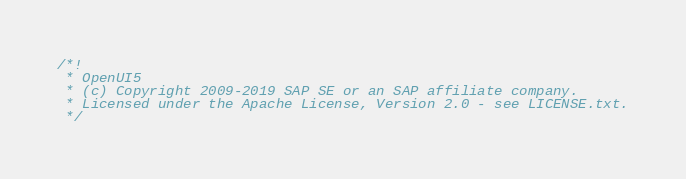Convert code to text. <code><loc_0><loc_0><loc_500><loc_500><_JavaScript_>/*!
 * OpenUI5
 * (c) Copyright 2009-2019 SAP SE or an SAP affiliate company.
 * Licensed under the Apache License, Version 2.0 - see LICENSE.txt.
 */</code> 